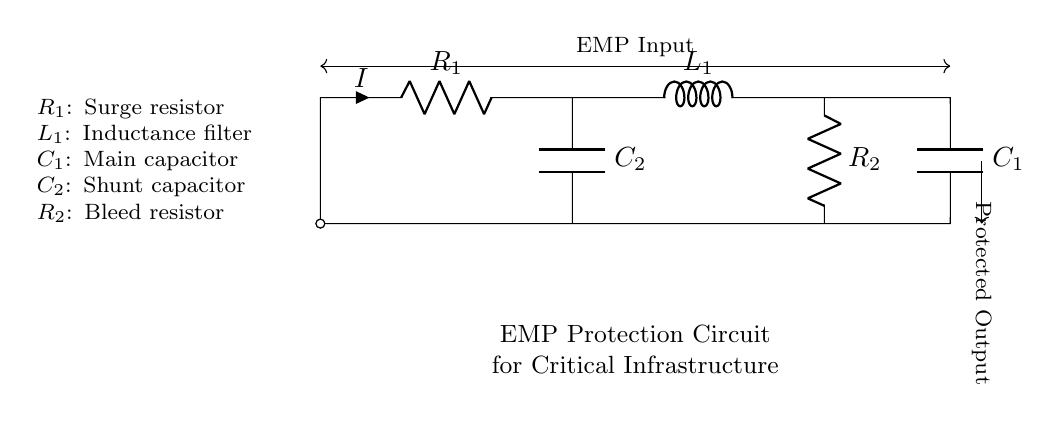What is the function of R1? R1 is a surge resistor designed to manage inrush currents and protect the circuit from voltage spikes during an electromagnetic pulse event.
Answer: Surge resistor What type of component is L1? L1 is an inductance filter, which serves to attenuate high-frequency noise and currents, protecting downstream components from fast transients.
Answer: Inductance filter How many capacitors are present in the circuit? There are two capacitors, C1 and C2, both of which contribute to smoothing and filtering effects in the circuit.
Answer: Two What is the role of C1? C1 is the main capacitor responsible for energy storage and providing surge protection by absorbing excess energy during an EMP.
Answer: Main capacitor Why is R2 necessary in this circuit? R2 acts as a bleed resistor, allowing the stored charge in C2 to discharge safely when the circuit is not in use, preventing unexpected shocks.
Answer: Bleed resistor How do C1 and C2 work together? C1 and C2 function in parallel to enhance the circuit's ability to absorb surges and maintain voltage stability during transient conditions.
Answer: Voltage stability 